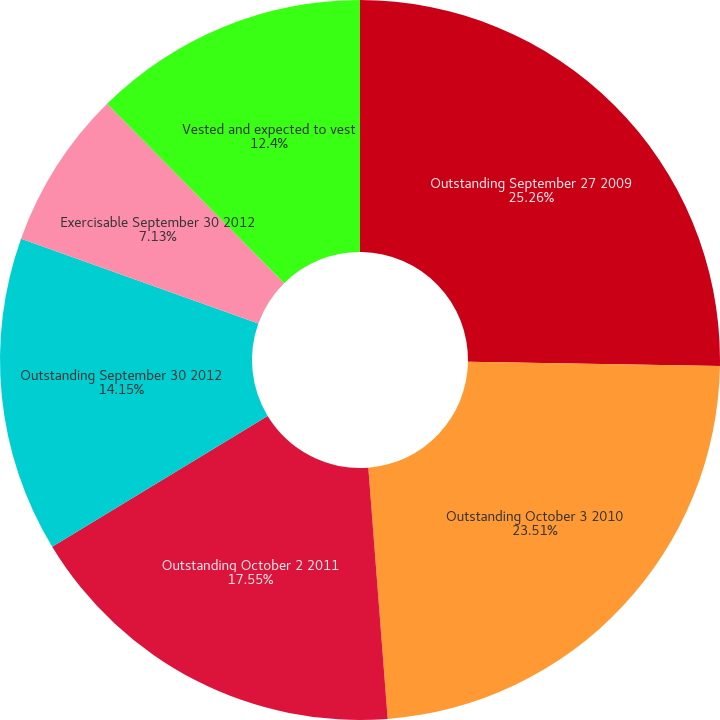<chart> <loc_0><loc_0><loc_500><loc_500><pie_chart><fcel>Outstanding September 27 2009<fcel>Outstanding October 3 2010<fcel>Outstanding October 2 2011<fcel>Outstanding September 30 2012<fcel>Exercisable September 30 2012<fcel>Vested and expected to vest<nl><fcel>25.27%<fcel>23.51%<fcel>17.55%<fcel>14.15%<fcel>7.13%<fcel>12.4%<nl></chart> 